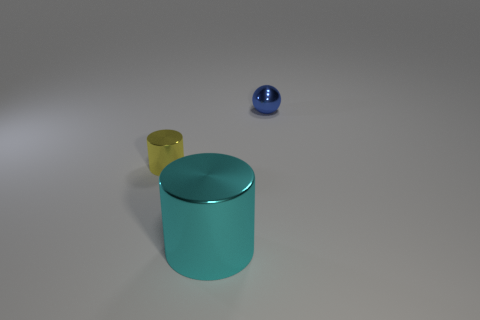Add 3 purple rubber objects. How many objects exist? 6 Subtract all cylinders. How many objects are left? 1 Subtract all big cylinders. Subtract all small metallic spheres. How many objects are left? 1 Add 3 blue spheres. How many blue spheres are left? 4 Add 1 gray cylinders. How many gray cylinders exist? 1 Subtract 1 blue balls. How many objects are left? 2 